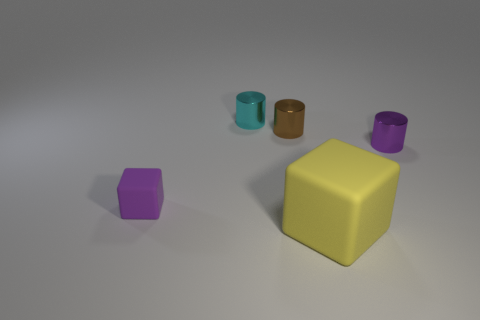How many other tiny cubes have the same material as the tiny purple block?
Provide a succinct answer. 0. The tiny object that is left of the purple cylinder and on the right side of the tiny cyan thing has what shape?
Provide a short and direct response. Cylinder. What number of things are blocks that are in front of the purple matte object or tiny objects on the left side of the large yellow thing?
Provide a succinct answer. 4. Is the number of big rubber cubes behind the cyan cylinder the same as the number of small brown shiny objects to the right of the purple block?
Provide a succinct answer. No. There is a small purple metal object behind the tiny purple object left of the large matte object; what shape is it?
Give a very brief answer. Cylinder. Are there any other rubber things that have the same shape as the tiny purple rubber object?
Keep it short and to the point. Yes. How many small cyan cylinders are there?
Your answer should be very brief. 1. Do the small purple thing that is to the right of the large rubber thing and the purple block have the same material?
Offer a very short reply. No. Are there any brown things of the same size as the cyan shiny object?
Offer a terse response. Yes. Does the tiny purple metallic object have the same shape as the small purple thing that is to the left of the small brown metallic thing?
Keep it short and to the point. No. 